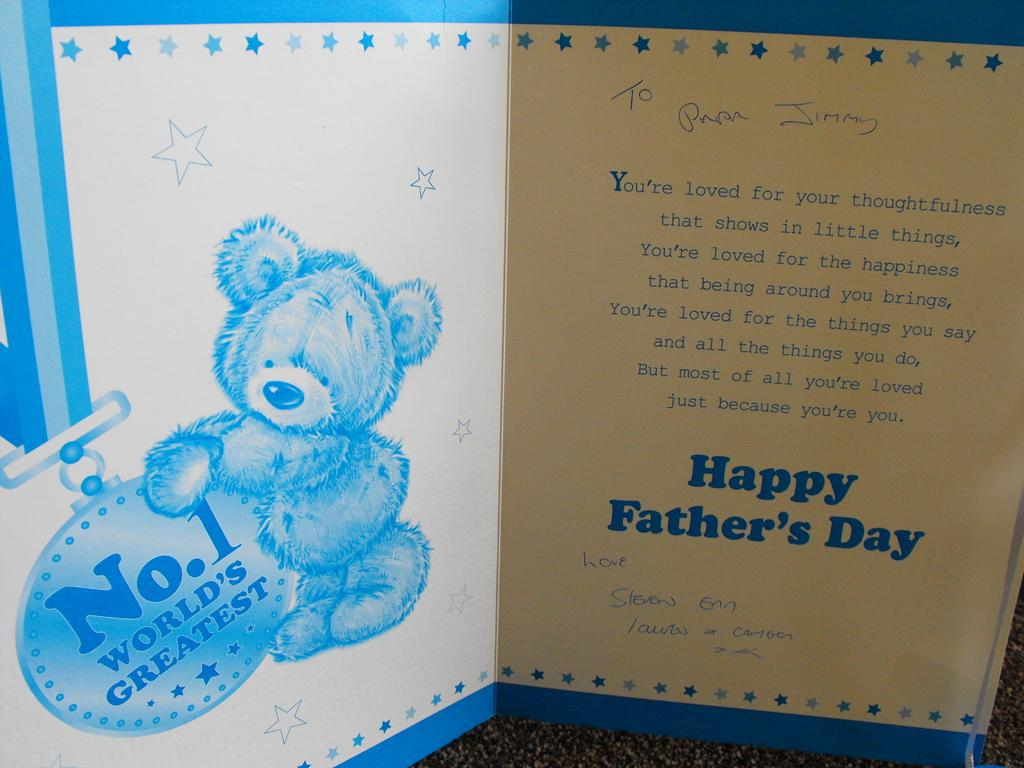What is the main object in the image? There is a greeting card in the image. What colors are used for the greeting card? The greeting card is in white and blue color. What is the background color of the surface where the greeting card is placed? The greeting card is on a black color surface. What message is written on the greeting card? The phrase "happy fathers day" is written on the greeting card. What type of horse can be seen running on the route mentioned on the greeting card? There is no mention of a horse or a route on the greeting card; it only says "happy fathers day." 